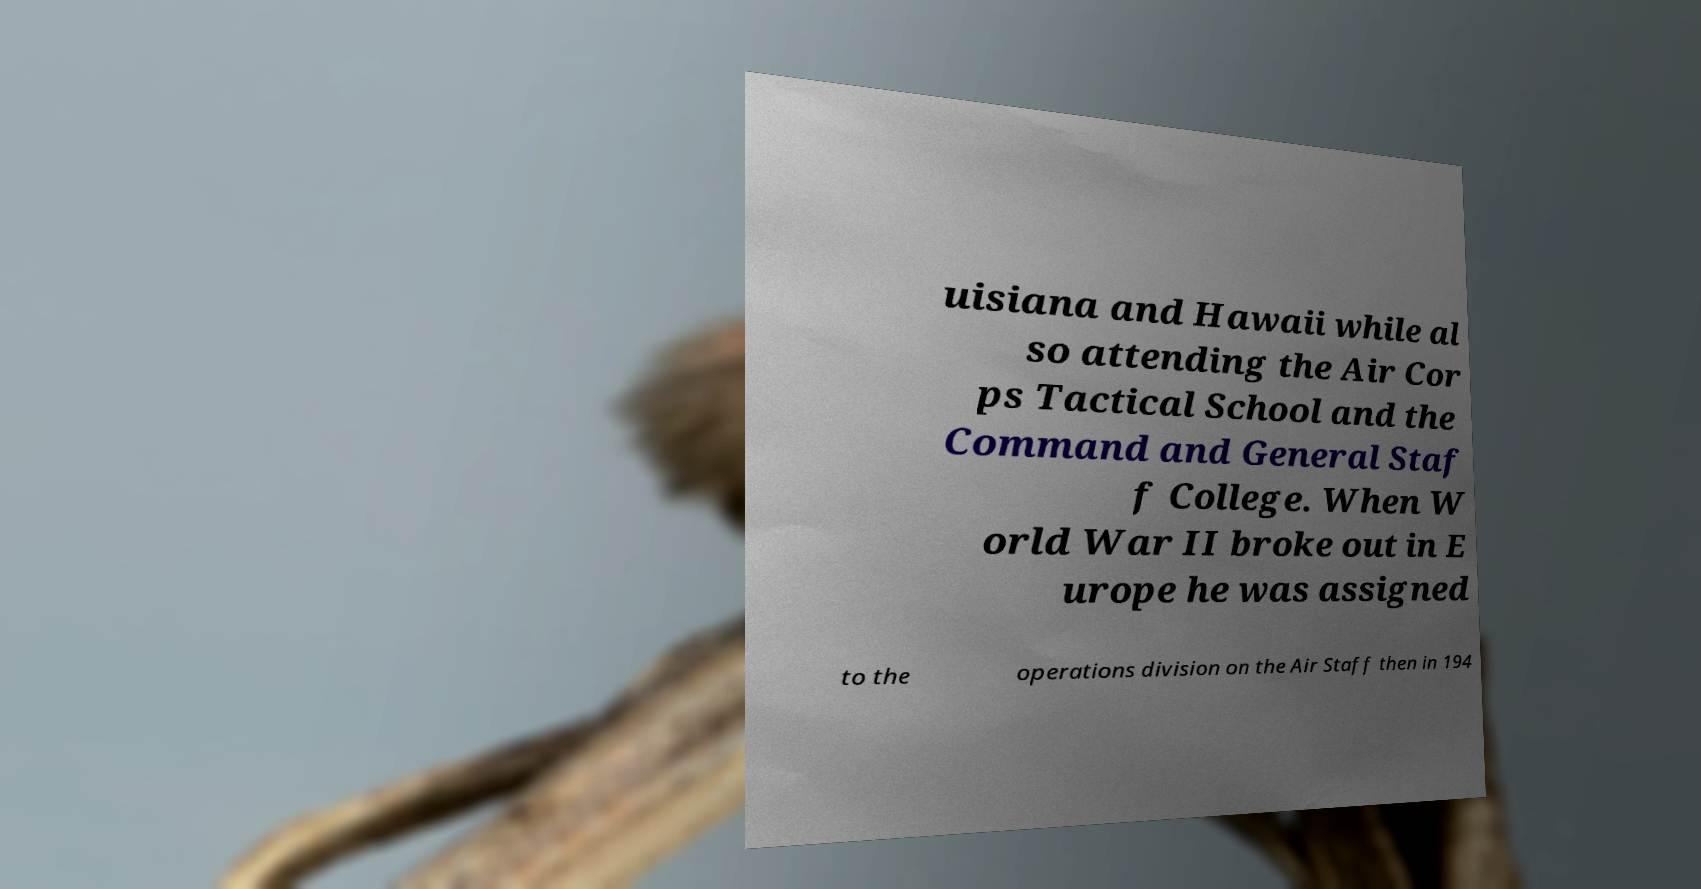What messages or text are displayed in this image? I need them in a readable, typed format. uisiana and Hawaii while al so attending the Air Cor ps Tactical School and the Command and General Staf f College. When W orld War II broke out in E urope he was assigned to the operations division on the Air Staff then in 194 